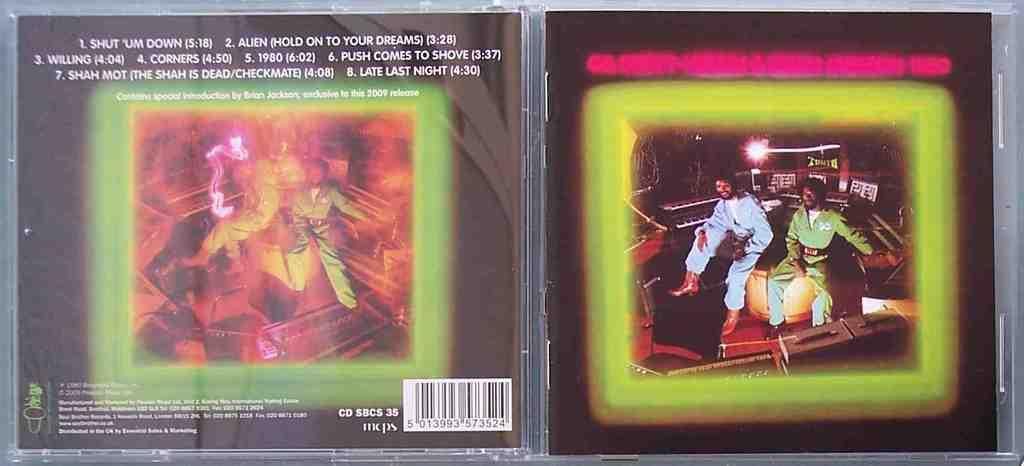Provide a one-sentence caption for the provided image. Compact disk album with special introduction by Brian Jackson. 